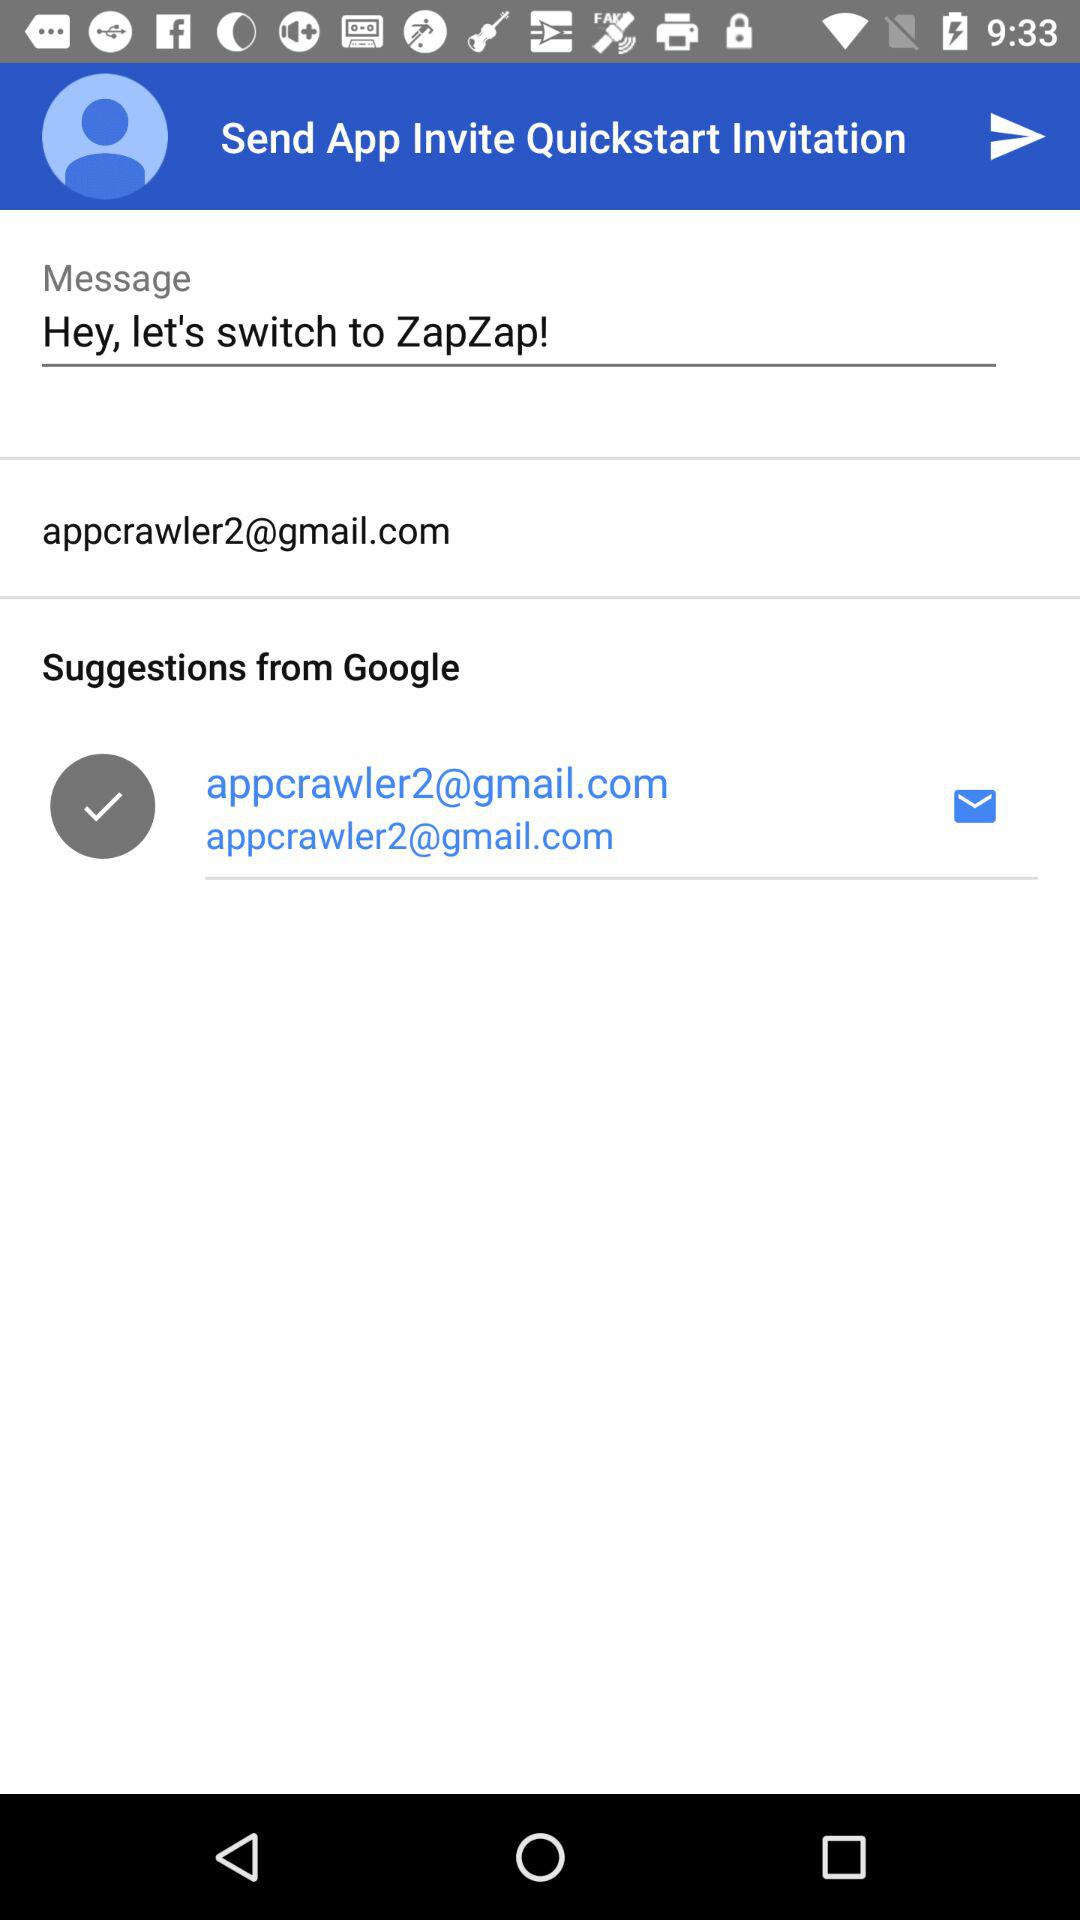What is the Gmail account shown? The Gmail account shown is "appcrawler2@gmail.com". 